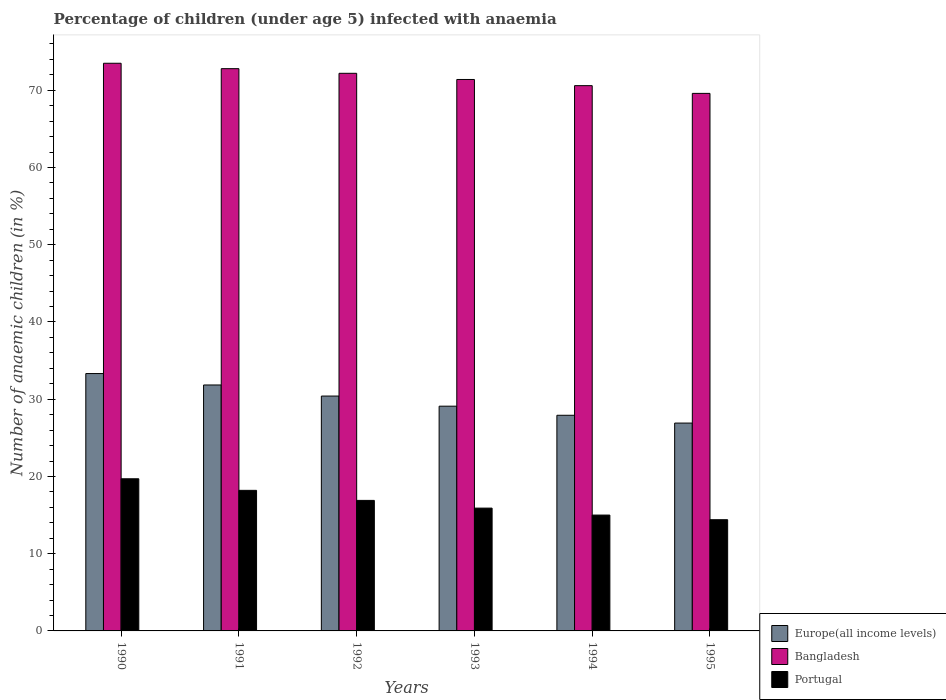How many different coloured bars are there?
Ensure brevity in your answer.  3. How many groups of bars are there?
Your answer should be compact. 6. Are the number of bars per tick equal to the number of legend labels?
Offer a terse response. Yes. How many bars are there on the 2nd tick from the left?
Make the answer very short. 3. How many bars are there on the 3rd tick from the right?
Make the answer very short. 3. What is the label of the 1st group of bars from the left?
Your answer should be compact. 1990. In how many cases, is the number of bars for a given year not equal to the number of legend labels?
Make the answer very short. 0. What is the percentage of children infected with anaemia in in Bangladesh in 1992?
Your answer should be compact. 72.2. Across all years, what is the maximum percentage of children infected with anaemia in in Bangladesh?
Your answer should be very brief. 73.5. Across all years, what is the minimum percentage of children infected with anaemia in in Portugal?
Your answer should be compact. 14.4. In which year was the percentage of children infected with anaemia in in Bangladesh minimum?
Provide a short and direct response. 1995. What is the total percentage of children infected with anaemia in in Europe(all income levels) in the graph?
Make the answer very short. 179.51. What is the difference between the percentage of children infected with anaemia in in Europe(all income levels) in 1994 and that in 1995?
Your response must be concise. 1.01. What is the average percentage of children infected with anaemia in in Europe(all income levels) per year?
Make the answer very short. 29.92. In the year 1991, what is the difference between the percentage of children infected with anaemia in in Bangladesh and percentage of children infected with anaemia in in Portugal?
Your answer should be compact. 54.6. In how many years, is the percentage of children infected with anaemia in in Europe(all income levels) greater than 52 %?
Offer a very short reply. 0. What is the ratio of the percentage of children infected with anaemia in in Europe(all income levels) in 1991 to that in 1993?
Provide a succinct answer. 1.09. What is the difference between the highest and the second highest percentage of children infected with anaemia in in Bangladesh?
Ensure brevity in your answer.  0.7. What is the difference between the highest and the lowest percentage of children infected with anaemia in in Europe(all income levels)?
Give a very brief answer. 6.41. What does the 1st bar from the left in 1995 represents?
Give a very brief answer. Europe(all income levels). What does the 3rd bar from the right in 1991 represents?
Offer a terse response. Europe(all income levels). Are all the bars in the graph horizontal?
Give a very brief answer. No. Does the graph contain any zero values?
Offer a terse response. No. Where does the legend appear in the graph?
Provide a succinct answer. Bottom right. What is the title of the graph?
Your answer should be compact. Percentage of children (under age 5) infected with anaemia. What is the label or title of the X-axis?
Offer a very short reply. Years. What is the label or title of the Y-axis?
Provide a short and direct response. Number of anaemic children (in %). What is the Number of anaemic children (in %) in Europe(all income levels) in 1990?
Make the answer very short. 33.32. What is the Number of anaemic children (in %) in Bangladesh in 1990?
Offer a very short reply. 73.5. What is the Number of anaemic children (in %) in Europe(all income levels) in 1991?
Give a very brief answer. 31.85. What is the Number of anaemic children (in %) of Bangladesh in 1991?
Your answer should be very brief. 72.8. What is the Number of anaemic children (in %) in Portugal in 1991?
Your response must be concise. 18.2. What is the Number of anaemic children (in %) of Europe(all income levels) in 1992?
Offer a terse response. 30.41. What is the Number of anaemic children (in %) in Bangladesh in 1992?
Offer a terse response. 72.2. What is the Number of anaemic children (in %) of Europe(all income levels) in 1993?
Your response must be concise. 29.1. What is the Number of anaemic children (in %) of Bangladesh in 1993?
Offer a terse response. 71.4. What is the Number of anaemic children (in %) of Portugal in 1993?
Your answer should be compact. 15.9. What is the Number of anaemic children (in %) of Europe(all income levels) in 1994?
Your answer should be compact. 27.92. What is the Number of anaemic children (in %) in Bangladesh in 1994?
Your answer should be very brief. 70.6. What is the Number of anaemic children (in %) of Europe(all income levels) in 1995?
Offer a terse response. 26.91. What is the Number of anaemic children (in %) of Bangladesh in 1995?
Keep it short and to the point. 69.6. What is the Number of anaemic children (in %) in Portugal in 1995?
Your answer should be very brief. 14.4. Across all years, what is the maximum Number of anaemic children (in %) in Europe(all income levels)?
Your answer should be very brief. 33.32. Across all years, what is the maximum Number of anaemic children (in %) of Bangladesh?
Give a very brief answer. 73.5. Across all years, what is the maximum Number of anaemic children (in %) in Portugal?
Your answer should be very brief. 19.7. Across all years, what is the minimum Number of anaemic children (in %) of Europe(all income levels)?
Your answer should be compact. 26.91. Across all years, what is the minimum Number of anaemic children (in %) in Bangladesh?
Offer a terse response. 69.6. Across all years, what is the minimum Number of anaemic children (in %) in Portugal?
Provide a succinct answer. 14.4. What is the total Number of anaemic children (in %) of Europe(all income levels) in the graph?
Your response must be concise. 179.51. What is the total Number of anaemic children (in %) of Bangladesh in the graph?
Your answer should be compact. 430.1. What is the total Number of anaemic children (in %) in Portugal in the graph?
Your answer should be very brief. 100.1. What is the difference between the Number of anaemic children (in %) in Europe(all income levels) in 1990 and that in 1991?
Ensure brevity in your answer.  1.48. What is the difference between the Number of anaemic children (in %) of Europe(all income levels) in 1990 and that in 1992?
Provide a short and direct response. 2.91. What is the difference between the Number of anaemic children (in %) of Europe(all income levels) in 1990 and that in 1993?
Make the answer very short. 4.22. What is the difference between the Number of anaemic children (in %) of Bangladesh in 1990 and that in 1993?
Offer a terse response. 2.1. What is the difference between the Number of anaemic children (in %) of Europe(all income levels) in 1990 and that in 1994?
Offer a terse response. 5.4. What is the difference between the Number of anaemic children (in %) in Bangladesh in 1990 and that in 1994?
Give a very brief answer. 2.9. What is the difference between the Number of anaemic children (in %) of Europe(all income levels) in 1990 and that in 1995?
Keep it short and to the point. 6.41. What is the difference between the Number of anaemic children (in %) of Portugal in 1990 and that in 1995?
Offer a terse response. 5.3. What is the difference between the Number of anaemic children (in %) of Europe(all income levels) in 1991 and that in 1992?
Your response must be concise. 1.43. What is the difference between the Number of anaemic children (in %) in Bangladesh in 1991 and that in 1992?
Your answer should be compact. 0.6. What is the difference between the Number of anaemic children (in %) in Europe(all income levels) in 1991 and that in 1993?
Your answer should be compact. 2.75. What is the difference between the Number of anaemic children (in %) of Europe(all income levels) in 1991 and that in 1994?
Offer a very short reply. 3.92. What is the difference between the Number of anaemic children (in %) of Portugal in 1991 and that in 1994?
Make the answer very short. 3.2. What is the difference between the Number of anaemic children (in %) in Europe(all income levels) in 1991 and that in 1995?
Keep it short and to the point. 4.93. What is the difference between the Number of anaemic children (in %) of Bangladesh in 1991 and that in 1995?
Give a very brief answer. 3.2. What is the difference between the Number of anaemic children (in %) in Europe(all income levels) in 1992 and that in 1993?
Make the answer very short. 1.31. What is the difference between the Number of anaemic children (in %) of Europe(all income levels) in 1992 and that in 1994?
Your response must be concise. 2.49. What is the difference between the Number of anaemic children (in %) of Europe(all income levels) in 1992 and that in 1995?
Provide a succinct answer. 3.5. What is the difference between the Number of anaemic children (in %) of Bangladesh in 1992 and that in 1995?
Give a very brief answer. 2.6. What is the difference between the Number of anaemic children (in %) in Europe(all income levels) in 1993 and that in 1994?
Your answer should be compact. 1.18. What is the difference between the Number of anaemic children (in %) in Bangladesh in 1993 and that in 1994?
Your answer should be very brief. 0.8. What is the difference between the Number of anaemic children (in %) in Portugal in 1993 and that in 1994?
Ensure brevity in your answer.  0.9. What is the difference between the Number of anaemic children (in %) of Europe(all income levels) in 1993 and that in 1995?
Offer a terse response. 2.19. What is the difference between the Number of anaemic children (in %) of Bangladesh in 1993 and that in 1995?
Your answer should be compact. 1.8. What is the difference between the Number of anaemic children (in %) in Europe(all income levels) in 1994 and that in 1995?
Your answer should be very brief. 1.01. What is the difference between the Number of anaemic children (in %) in Bangladesh in 1994 and that in 1995?
Keep it short and to the point. 1. What is the difference between the Number of anaemic children (in %) of Europe(all income levels) in 1990 and the Number of anaemic children (in %) of Bangladesh in 1991?
Make the answer very short. -39.48. What is the difference between the Number of anaemic children (in %) of Europe(all income levels) in 1990 and the Number of anaemic children (in %) of Portugal in 1991?
Ensure brevity in your answer.  15.12. What is the difference between the Number of anaemic children (in %) of Bangladesh in 1990 and the Number of anaemic children (in %) of Portugal in 1991?
Your response must be concise. 55.3. What is the difference between the Number of anaemic children (in %) of Europe(all income levels) in 1990 and the Number of anaemic children (in %) of Bangladesh in 1992?
Your answer should be very brief. -38.88. What is the difference between the Number of anaemic children (in %) in Europe(all income levels) in 1990 and the Number of anaemic children (in %) in Portugal in 1992?
Your response must be concise. 16.42. What is the difference between the Number of anaemic children (in %) of Bangladesh in 1990 and the Number of anaemic children (in %) of Portugal in 1992?
Provide a short and direct response. 56.6. What is the difference between the Number of anaemic children (in %) of Europe(all income levels) in 1990 and the Number of anaemic children (in %) of Bangladesh in 1993?
Offer a very short reply. -38.08. What is the difference between the Number of anaemic children (in %) of Europe(all income levels) in 1990 and the Number of anaemic children (in %) of Portugal in 1993?
Your response must be concise. 17.42. What is the difference between the Number of anaemic children (in %) of Bangladesh in 1990 and the Number of anaemic children (in %) of Portugal in 1993?
Ensure brevity in your answer.  57.6. What is the difference between the Number of anaemic children (in %) of Europe(all income levels) in 1990 and the Number of anaemic children (in %) of Bangladesh in 1994?
Your response must be concise. -37.28. What is the difference between the Number of anaemic children (in %) in Europe(all income levels) in 1990 and the Number of anaemic children (in %) in Portugal in 1994?
Offer a very short reply. 18.32. What is the difference between the Number of anaemic children (in %) of Bangladesh in 1990 and the Number of anaemic children (in %) of Portugal in 1994?
Provide a succinct answer. 58.5. What is the difference between the Number of anaemic children (in %) in Europe(all income levels) in 1990 and the Number of anaemic children (in %) in Bangladesh in 1995?
Your answer should be very brief. -36.28. What is the difference between the Number of anaemic children (in %) of Europe(all income levels) in 1990 and the Number of anaemic children (in %) of Portugal in 1995?
Your response must be concise. 18.92. What is the difference between the Number of anaemic children (in %) of Bangladesh in 1990 and the Number of anaemic children (in %) of Portugal in 1995?
Make the answer very short. 59.1. What is the difference between the Number of anaemic children (in %) of Europe(all income levels) in 1991 and the Number of anaemic children (in %) of Bangladesh in 1992?
Provide a succinct answer. -40.35. What is the difference between the Number of anaemic children (in %) of Europe(all income levels) in 1991 and the Number of anaemic children (in %) of Portugal in 1992?
Your answer should be very brief. 14.95. What is the difference between the Number of anaemic children (in %) in Bangladesh in 1991 and the Number of anaemic children (in %) in Portugal in 1992?
Provide a succinct answer. 55.9. What is the difference between the Number of anaemic children (in %) of Europe(all income levels) in 1991 and the Number of anaemic children (in %) of Bangladesh in 1993?
Offer a terse response. -39.55. What is the difference between the Number of anaemic children (in %) of Europe(all income levels) in 1991 and the Number of anaemic children (in %) of Portugal in 1993?
Provide a short and direct response. 15.95. What is the difference between the Number of anaemic children (in %) in Bangladesh in 1991 and the Number of anaemic children (in %) in Portugal in 1993?
Offer a very short reply. 56.9. What is the difference between the Number of anaemic children (in %) of Europe(all income levels) in 1991 and the Number of anaemic children (in %) of Bangladesh in 1994?
Your answer should be compact. -38.75. What is the difference between the Number of anaemic children (in %) of Europe(all income levels) in 1991 and the Number of anaemic children (in %) of Portugal in 1994?
Your response must be concise. 16.85. What is the difference between the Number of anaemic children (in %) of Bangladesh in 1991 and the Number of anaemic children (in %) of Portugal in 1994?
Give a very brief answer. 57.8. What is the difference between the Number of anaemic children (in %) in Europe(all income levels) in 1991 and the Number of anaemic children (in %) in Bangladesh in 1995?
Provide a short and direct response. -37.75. What is the difference between the Number of anaemic children (in %) in Europe(all income levels) in 1991 and the Number of anaemic children (in %) in Portugal in 1995?
Your answer should be very brief. 17.45. What is the difference between the Number of anaemic children (in %) in Bangladesh in 1991 and the Number of anaemic children (in %) in Portugal in 1995?
Offer a very short reply. 58.4. What is the difference between the Number of anaemic children (in %) in Europe(all income levels) in 1992 and the Number of anaemic children (in %) in Bangladesh in 1993?
Your answer should be compact. -40.99. What is the difference between the Number of anaemic children (in %) of Europe(all income levels) in 1992 and the Number of anaemic children (in %) of Portugal in 1993?
Your response must be concise. 14.51. What is the difference between the Number of anaemic children (in %) of Bangladesh in 1992 and the Number of anaemic children (in %) of Portugal in 1993?
Provide a succinct answer. 56.3. What is the difference between the Number of anaemic children (in %) in Europe(all income levels) in 1992 and the Number of anaemic children (in %) in Bangladesh in 1994?
Give a very brief answer. -40.19. What is the difference between the Number of anaemic children (in %) in Europe(all income levels) in 1992 and the Number of anaemic children (in %) in Portugal in 1994?
Give a very brief answer. 15.41. What is the difference between the Number of anaemic children (in %) in Bangladesh in 1992 and the Number of anaemic children (in %) in Portugal in 1994?
Your answer should be compact. 57.2. What is the difference between the Number of anaemic children (in %) in Europe(all income levels) in 1992 and the Number of anaemic children (in %) in Bangladesh in 1995?
Give a very brief answer. -39.19. What is the difference between the Number of anaemic children (in %) of Europe(all income levels) in 1992 and the Number of anaemic children (in %) of Portugal in 1995?
Keep it short and to the point. 16.01. What is the difference between the Number of anaemic children (in %) of Bangladesh in 1992 and the Number of anaemic children (in %) of Portugal in 1995?
Provide a succinct answer. 57.8. What is the difference between the Number of anaemic children (in %) in Europe(all income levels) in 1993 and the Number of anaemic children (in %) in Bangladesh in 1994?
Ensure brevity in your answer.  -41.5. What is the difference between the Number of anaemic children (in %) of Europe(all income levels) in 1993 and the Number of anaemic children (in %) of Portugal in 1994?
Provide a succinct answer. 14.1. What is the difference between the Number of anaemic children (in %) in Bangladesh in 1993 and the Number of anaemic children (in %) in Portugal in 1994?
Make the answer very short. 56.4. What is the difference between the Number of anaemic children (in %) in Europe(all income levels) in 1993 and the Number of anaemic children (in %) in Bangladesh in 1995?
Offer a very short reply. -40.5. What is the difference between the Number of anaemic children (in %) of Europe(all income levels) in 1993 and the Number of anaemic children (in %) of Portugal in 1995?
Keep it short and to the point. 14.7. What is the difference between the Number of anaemic children (in %) in Bangladesh in 1993 and the Number of anaemic children (in %) in Portugal in 1995?
Your answer should be compact. 57. What is the difference between the Number of anaemic children (in %) of Europe(all income levels) in 1994 and the Number of anaemic children (in %) of Bangladesh in 1995?
Provide a short and direct response. -41.68. What is the difference between the Number of anaemic children (in %) of Europe(all income levels) in 1994 and the Number of anaemic children (in %) of Portugal in 1995?
Provide a succinct answer. 13.52. What is the difference between the Number of anaemic children (in %) in Bangladesh in 1994 and the Number of anaemic children (in %) in Portugal in 1995?
Your response must be concise. 56.2. What is the average Number of anaemic children (in %) of Europe(all income levels) per year?
Keep it short and to the point. 29.92. What is the average Number of anaemic children (in %) in Bangladesh per year?
Keep it short and to the point. 71.68. What is the average Number of anaemic children (in %) in Portugal per year?
Offer a terse response. 16.68. In the year 1990, what is the difference between the Number of anaemic children (in %) in Europe(all income levels) and Number of anaemic children (in %) in Bangladesh?
Make the answer very short. -40.18. In the year 1990, what is the difference between the Number of anaemic children (in %) in Europe(all income levels) and Number of anaemic children (in %) in Portugal?
Make the answer very short. 13.62. In the year 1990, what is the difference between the Number of anaemic children (in %) of Bangladesh and Number of anaemic children (in %) of Portugal?
Make the answer very short. 53.8. In the year 1991, what is the difference between the Number of anaemic children (in %) of Europe(all income levels) and Number of anaemic children (in %) of Bangladesh?
Your answer should be very brief. -40.95. In the year 1991, what is the difference between the Number of anaemic children (in %) of Europe(all income levels) and Number of anaemic children (in %) of Portugal?
Your answer should be compact. 13.65. In the year 1991, what is the difference between the Number of anaemic children (in %) of Bangladesh and Number of anaemic children (in %) of Portugal?
Your response must be concise. 54.6. In the year 1992, what is the difference between the Number of anaemic children (in %) of Europe(all income levels) and Number of anaemic children (in %) of Bangladesh?
Provide a succinct answer. -41.79. In the year 1992, what is the difference between the Number of anaemic children (in %) of Europe(all income levels) and Number of anaemic children (in %) of Portugal?
Provide a succinct answer. 13.51. In the year 1992, what is the difference between the Number of anaemic children (in %) of Bangladesh and Number of anaemic children (in %) of Portugal?
Make the answer very short. 55.3. In the year 1993, what is the difference between the Number of anaemic children (in %) in Europe(all income levels) and Number of anaemic children (in %) in Bangladesh?
Keep it short and to the point. -42.3. In the year 1993, what is the difference between the Number of anaemic children (in %) of Europe(all income levels) and Number of anaemic children (in %) of Portugal?
Give a very brief answer. 13.2. In the year 1993, what is the difference between the Number of anaemic children (in %) of Bangladesh and Number of anaemic children (in %) of Portugal?
Give a very brief answer. 55.5. In the year 1994, what is the difference between the Number of anaemic children (in %) in Europe(all income levels) and Number of anaemic children (in %) in Bangladesh?
Your answer should be very brief. -42.68. In the year 1994, what is the difference between the Number of anaemic children (in %) of Europe(all income levels) and Number of anaemic children (in %) of Portugal?
Offer a very short reply. 12.92. In the year 1994, what is the difference between the Number of anaemic children (in %) of Bangladesh and Number of anaemic children (in %) of Portugal?
Offer a terse response. 55.6. In the year 1995, what is the difference between the Number of anaemic children (in %) of Europe(all income levels) and Number of anaemic children (in %) of Bangladesh?
Ensure brevity in your answer.  -42.69. In the year 1995, what is the difference between the Number of anaemic children (in %) of Europe(all income levels) and Number of anaemic children (in %) of Portugal?
Keep it short and to the point. 12.51. In the year 1995, what is the difference between the Number of anaemic children (in %) in Bangladesh and Number of anaemic children (in %) in Portugal?
Give a very brief answer. 55.2. What is the ratio of the Number of anaemic children (in %) of Europe(all income levels) in 1990 to that in 1991?
Offer a terse response. 1.05. What is the ratio of the Number of anaemic children (in %) of Bangladesh in 1990 to that in 1991?
Your answer should be very brief. 1.01. What is the ratio of the Number of anaemic children (in %) of Portugal in 1990 to that in 1991?
Give a very brief answer. 1.08. What is the ratio of the Number of anaemic children (in %) of Europe(all income levels) in 1990 to that in 1992?
Your answer should be very brief. 1.1. What is the ratio of the Number of anaemic children (in %) of Bangladesh in 1990 to that in 1992?
Ensure brevity in your answer.  1.02. What is the ratio of the Number of anaemic children (in %) of Portugal in 1990 to that in 1992?
Make the answer very short. 1.17. What is the ratio of the Number of anaemic children (in %) in Europe(all income levels) in 1990 to that in 1993?
Provide a short and direct response. 1.15. What is the ratio of the Number of anaemic children (in %) in Bangladesh in 1990 to that in 1993?
Ensure brevity in your answer.  1.03. What is the ratio of the Number of anaemic children (in %) in Portugal in 1990 to that in 1993?
Provide a succinct answer. 1.24. What is the ratio of the Number of anaemic children (in %) in Europe(all income levels) in 1990 to that in 1994?
Offer a very short reply. 1.19. What is the ratio of the Number of anaemic children (in %) in Bangladesh in 1990 to that in 1994?
Keep it short and to the point. 1.04. What is the ratio of the Number of anaemic children (in %) of Portugal in 1990 to that in 1994?
Your answer should be very brief. 1.31. What is the ratio of the Number of anaemic children (in %) in Europe(all income levels) in 1990 to that in 1995?
Provide a succinct answer. 1.24. What is the ratio of the Number of anaemic children (in %) of Bangladesh in 1990 to that in 1995?
Ensure brevity in your answer.  1.06. What is the ratio of the Number of anaemic children (in %) of Portugal in 1990 to that in 1995?
Your answer should be compact. 1.37. What is the ratio of the Number of anaemic children (in %) of Europe(all income levels) in 1991 to that in 1992?
Your answer should be very brief. 1.05. What is the ratio of the Number of anaemic children (in %) of Bangladesh in 1991 to that in 1992?
Keep it short and to the point. 1.01. What is the ratio of the Number of anaemic children (in %) in Europe(all income levels) in 1991 to that in 1993?
Offer a terse response. 1.09. What is the ratio of the Number of anaemic children (in %) of Bangladesh in 1991 to that in 1993?
Offer a terse response. 1.02. What is the ratio of the Number of anaemic children (in %) of Portugal in 1991 to that in 1993?
Offer a terse response. 1.14. What is the ratio of the Number of anaemic children (in %) of Europe(all income levels) in 1991 to that in 1994?
Offer a very short reply. 1.14. What is the ratio of the Number of anaemic children (in %) in Bangladesh in 1991 to that in 1994?
Provide a succinct answer. 1.03. What is the ratio of the Number of anaemic children (in %) of Portugal in 1991 to that in 1994?
Your answer should be compact. 1.21. What is the ratio of the Number of anaemic children (in %) of Europe(all income levels) in 1991 to that in 1995?
Provide a succinct answer. 1.18. What is the ratio of the Number of anaemic children (in %) in Bangladesh in 1991 to that in 1995?
Provide a short and direct response. 1.05. What is the ratio of the Number of anaemic children (in %) of Portugal in 1991 to that in 1995?
Provide a short and direct response. 1.26. What is the ratio of the Number of anaemic children (in %) in Europe(all income levels) in 1992 to that in 1993?
Keep it short and to the point. 1.04. What is the ratio of the Number of anaemic children (in %) in Bangladesh in 1992 to that in 1993?
Your response must be concise. 1.01. What is the ratio of the Number of anaemic children (in %) of Portugal in 1992 to that in 1993?
Provide a succinct answer. 1.06. What is the ratio of the Number of anaemic children (in %) of Europe(all income levels) in 1992 to that in 1994?
Offer a very short reply. 1.09. What is the ratio of the Number of anaemic children (in %) of Bangladesh in 1992 to that in 1994?
Provide a succinct answer. 1.02. What is the ratio of the Number of anaemic children (in %) of Portugal in 1992 to that in 1994?
Provide a succinct answer. 1.13. What is the ratio of the Number of anaemic children (in %) in Europe(all income levels) in 1992 to that in 1995?
Ensure brevity in your answer.  1.13. What is the ratio of the Number of anaemic children (in %) in Bangladesh in 1992 to that in 1995?
Your answer should be compact. 1.04. What is the ratio of the Number of anaemic children (in %) of Portugal in 1992 to that in 1995?
Keep it short and to the point. 1.17. What is the ratio of the Number of anaemic children (in %) of Europe(all income levels) in 1993 to that in 1994?
Make the answer very short. 1.04. What is the ratio of the Number of anaemic children (in %) in Bangladesh in 1993 to that in 1994?
Your response must be concise. 1.01. What is the ratio of the Number of anaemic children (in %) in Portugal in 1993 to that in 1994?
Your answer should be very brief. 1.06. What is the ratio of the Number of anaemic children (in %) of Europe(all income levels) in 1993 to that in 1995?
Give a very brief answer. 1.08. What is the ratio of the Number of anaemic children (in %) in Bangladesh in 1993 to that in 1995?
Provide a short and direct response. 1.03. What is the ratio of the Number of anaemic children (in %) of Portugal in 1993 to that in 1995?
Offer a terse response. 1.1. What is the ratio of the Number of anaemic children (in %) in Europe(all income levels) in 1994 to that in 1995?
Offer a terse response. 1.04. What is the ratio of the Number of anaemic children (in %) in Bangladesh in 1994 to that in 1995?
Ensure brevity in your answer.  1.01. What is the ratio of the Number of anaemic children (in %) in Portugal in 1994 to that in 1995?
Provide a succinct answer. 1.04. What is the difference between the highest and the second highest Number of anaemic children (in %) of Europe(all income levels)?
Make the answer very short. 1.48. What is the difference between the highest and the lowest Number of anaemic children (in %) of Europe(all income levels)?
Provide a succinct answer. 6.41. What is the difference between the highest and the lowest Number of anaemic children (in %) of Portugal?
Your response must be concise. 5.3. 